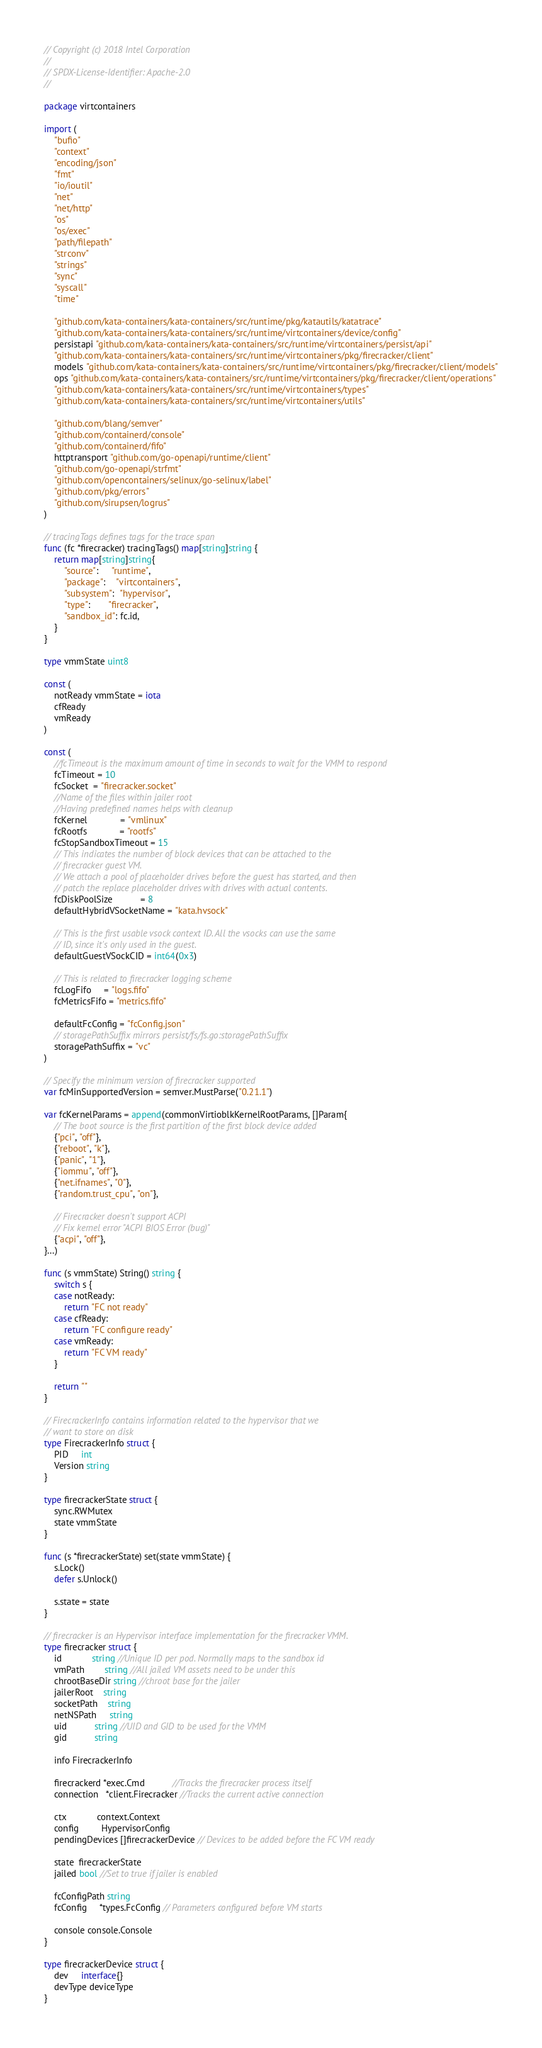<code> <loc_0><loc_0><loc_500><loc_500><_Go_>// Copyright (c) 2018 Intel Corporation
//
// SPDX-License-Identifier: Apache-2.0
//

package virtcontainers

import (
	"bufio"
	"context"
	"encoding/json"
	"fmt"
	"io/ioutil"
	"net"
	"net/http"
	"os"
	"os/exec"
	"path/filepath"
	"strconv"
	"strings"
	"sync"
	"syscall"
	"time"

	"github.com/kata-containers/kata-containers/src/runtime/pkg/katautils/katatrace"
	"github.com/kata-containers/kata-containers/src/runtime/virtcontainers/device/config"
	persistapi "github.com/kata-containers/kata-containers/src/runtime/virtcontainers/persist/api"
	"github.com/kata-containers/kata-containers/src/runtime/virtcontainers/pkg/firecracker/client"
	models "github.com/kata-containers/kata-containers/src/runtime/virtcontainers/pkg/firecracker/client/models"
	ops "github.com/kata-containers/kata-containers/src/runtime/virtcontainers/pkg/firecracker/client/operations"
	"github.com/kata-containers/kata-containers/src/runtime/virtcontainers/types"
	"github.com/kata-containers/kata-containers/src/runtime/virtcontainers/utils"

	"github.com/blang/semver"
	"github.com/containerd/console"
	"github.com/containerd/fifo"
	httptransport "github.com/go-openapi/runtime/client"
	"github.com/go-openapi/strfmt"
	"github.com/opencontainers/selinux/go-selinux/label"
	"github.com/pkg/errors"
	"github.com/sirupsen/logrus"
)

// tracingTags defines tags for the trace span
func (fc *firecracker) tracingTags() map[string]string {
	return map[string]string{
		"source":     "runtime",
		"package":    "virtcontainers",
		"subsystem":  "hypervisor",
		"type":       "firecracker",
		"sandbox_id": fc.id,
	}
}

type vmmState uint8

const (
	notReady vmmState = iota
	cfReady
	vmReady
)

const (
	//fcTimeout is the maximum amount of time in seconds to wait for the VMM to respond
	fcTimeout = 10
	fcSocket  = "firecracker.socket"
	//Name of the files within jailer root
	//Having predefined names helps with cleanup
	fcKernel             = "vmlinux"
	fcRootfs             = "rootfs"
	fcStopSandboxTimeout = 15
	// This indicates the number of block devices that can be attached to the
	// firecracker guest VM.
	// We attach a pool of placeholder drives before the guest has started, and then
	// patch the replace placeholder drives with drives with actual contents.
	fcDiskPoolSize           = 8
	defaultHybridVSocketName = "kata.hvsock"

	// This is the first usable vsock context ID. All the vsocks can use the same
	// ID, since it's only used in the guest.
	defaultGuestVSockCID = int64(0x3)

	// This is related to firecracker logging scheme
	fcLogFifo     = "logs.fifo"
	fcMetricsFifo = "metrics.fifo"

	defaultFcConfig = "fcConfig.json"
	// storagePathSuffix mirrors persist/fs/fs.go:storagePathSuffix
	storagePathSuffix = "vc"
)

// Specify the minimum version of firecracker supported
var fcMinSupportedVersion = semver.MustParse("0.21.1")

var fcKernelParams = append(commonVirtioblkKernelRootParams, []Param{
	// The boot source is the first partition of the first block device added
	{"pci", "off"},
	{"reboot", "k"},
	{"panic", "1"},
	{"iommu", "off"},
	{"net.ifnames", "0"},
	{"random.trust_cpu", "on"},

	// Firecracker doesn't support ACPI
	// Fix kernel error "ACPI BIOS Error (bug)"
	{"acpi", "off"},
}...)

func (s vmmState) String() string {
	switch s {
	case notReady:
		return "FC not ready"
	case cfReady:
		return "FC configure ready"
	case vmReady:
		return "FC VM ready"
	}

	return ""
}

// FirecrackerInfo contains information related to the hypervisor that we
// want to store on disk
type FirecrackerInfo struct {
	PID     int
	Version string
}

type firecrackerState struct {
	sync.RWMutex
	state vmmState
}

func (s *firecrackerState) set(state vmmState) {
	s.Lock()
	defer s.Unlock()

	s.state = state
}

// firecracker is an Hypervisor interface implementation for the firecracker VMM.
type firecracker struct {
	id            string //Unique ID per pod. Normally maps to the sandbox id
	vmPath        string //All jailed VM assets need to be under this
	chrootBaseDir string //chroot base for the jailer
	jailerRoot    string
	socketPath    string
	netNSPath     string
	uid           string //UID and GID to be used for the VMM
	gid           string

	info FirecrackerInfo

	firecrackerd *exec.Cmd           //Tracks the firecracker process itself
	connection   *client.Firecracker //Tracks the current active connection

	ctx            context.Context
	config         HypervisorConfig
	pendingDevices []firecrackerDevice // Devices to be added before the FC VM ready

	state  firecrackerState
	jailed bool //Set to true if jailer is enabled

	fcConfigPath string
	fcConfig     *types.FcConfig // Parameters configured before VM starts

	console console.Console
}

type firecrackerDevice struct {
	dev     interface{}
	devType deviceType
}
</code> 